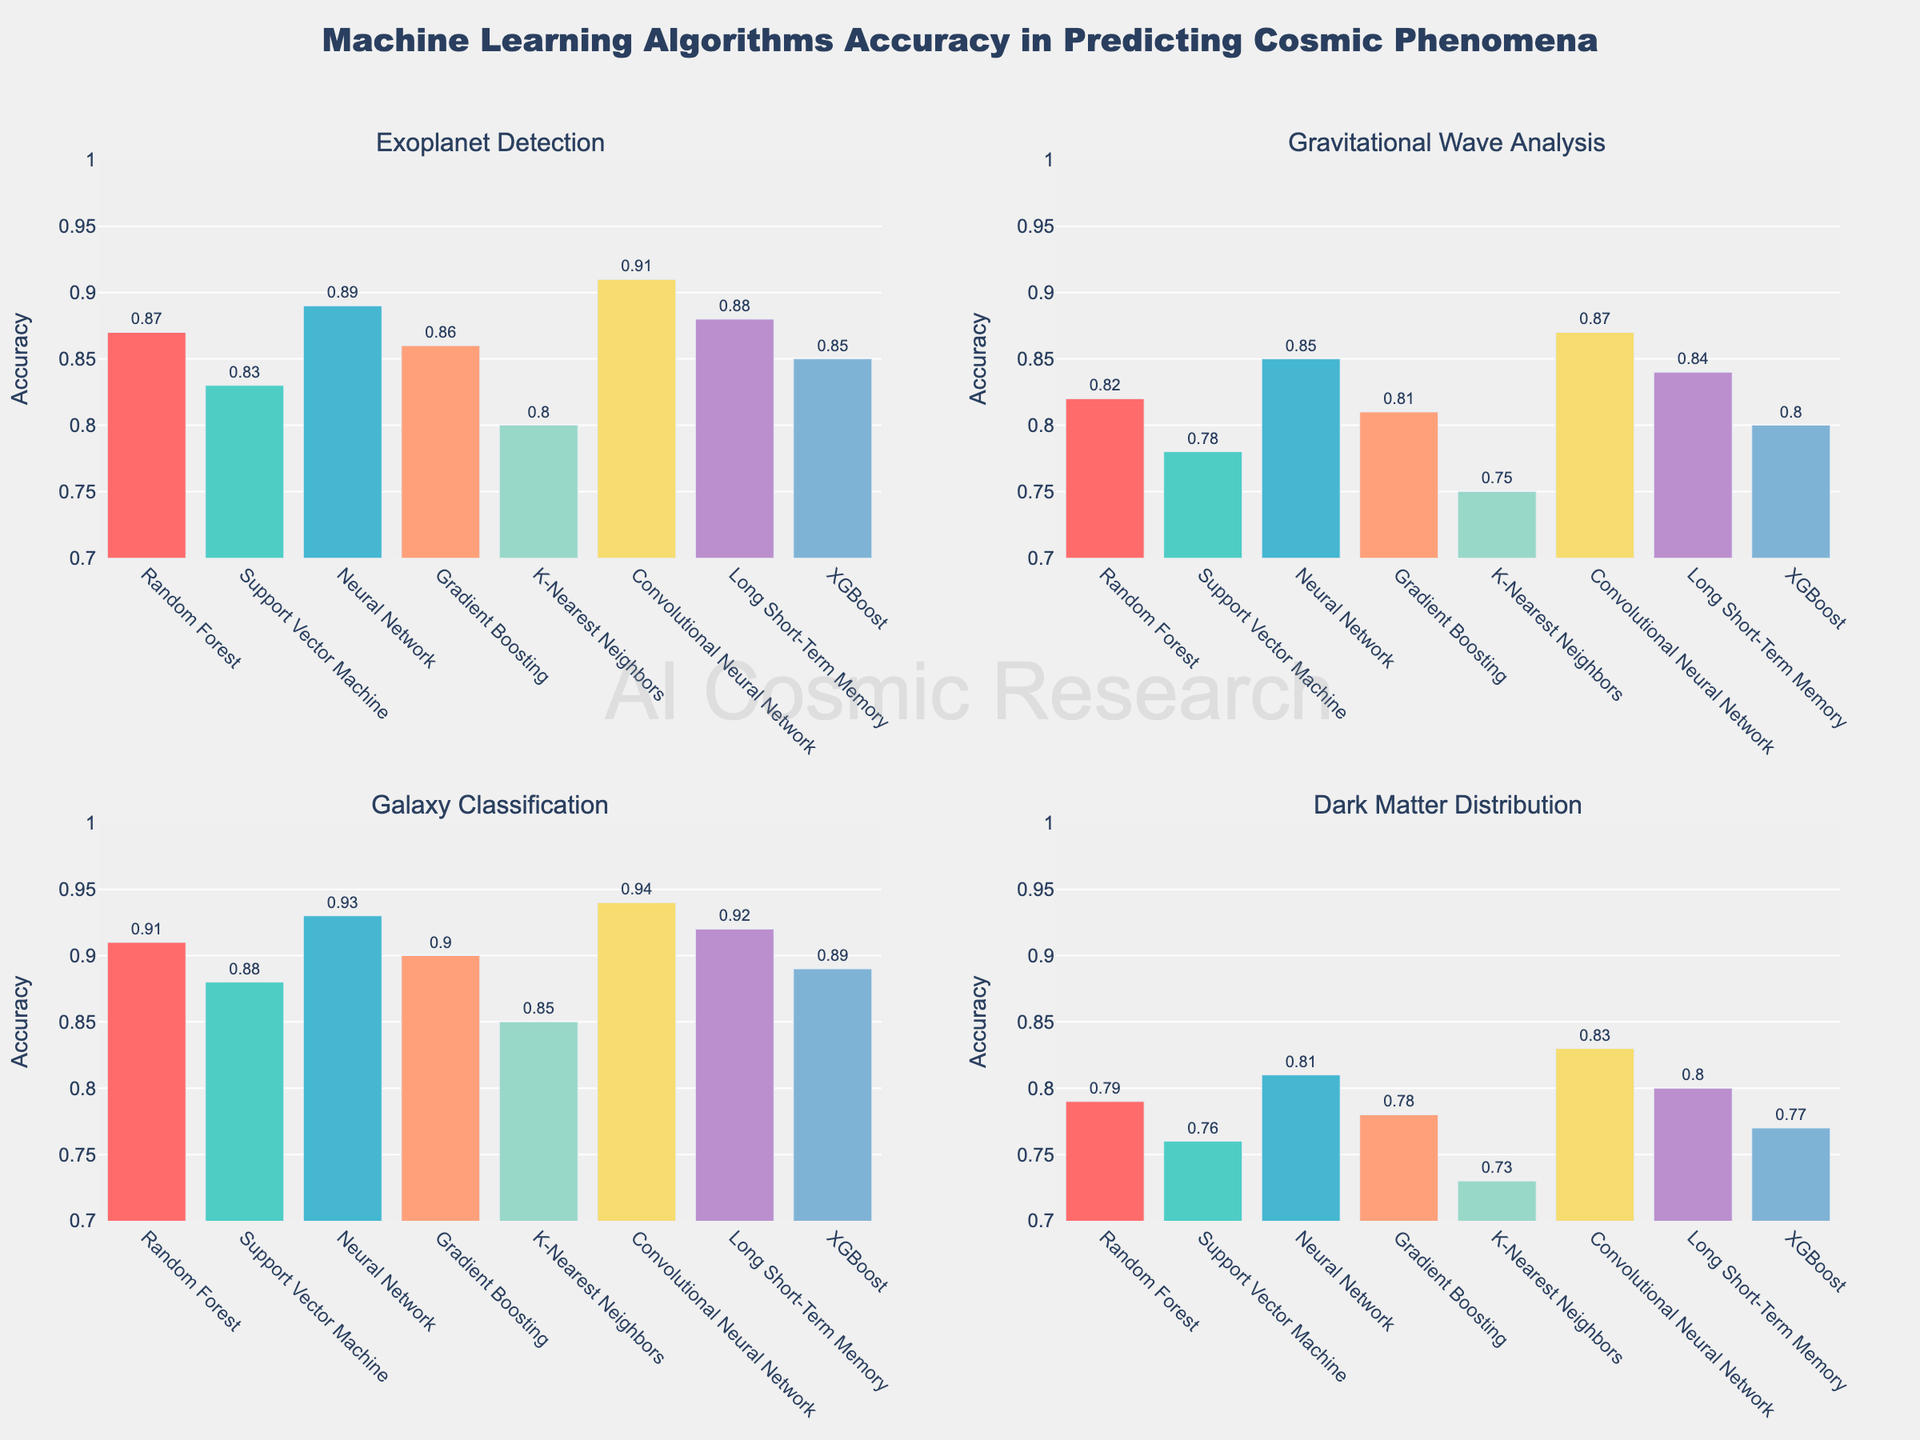What's the highest accuracy achieved by any algorithm in detecting Exoplanets? First, look at the 'Exoplanet Detection' subplot and identify the tallest bar. The tallest bar corresponds to the Convolutional Neural Network (CNN) algorithm with an accuracy of 0.91 (highlighted by its text label).
Answer: 0.91 Which phenomenon has the lowest overall accuracy across all algorithms? Evaluate all four subplots and note the lowest accuracies in each. Gravitational Wave Analysis and Dark Matter Distribution have noticeably lower maximum accuracies. Dark Matter Distribution has the lowest maximum accuracy, with 0.83 achieved by the CNN algorithm.
Answer: Dark Matter Distribution What is the difference in accuracy between the highest and lowest performing algorithms in Galaxy Classification? Identify the tallest and shortest bars in the Galaxy Classification subplot. Neural Network achieves the highest accuracy (0.94), while K-Nearest Neighbors achieves the lowest (0.85). Compute the difference: 0.94 - 0.85.
Answer: 0.09 On average, which algorithm performs the best across all phenomena? Calculate the average accuracy for each algorithm across the four phenomena. Neural Network shows consistently high accuracy: (0.89 + 0.85 + 0.93 + 0.81) / 4 = 0.87 on average. CNN 0.91, 0.87, 0.94, and 0.83 results in 0.88, thus making CNN the algorithm with the highest average accuracy.
Answer: Convolutional Neural Network Compare Random Forest and Support Vector Machine in terms of their accuracy in detecting Exoplanets. Which one is higher and by how much? Refer to the Exoplanet Detection subplot, Random Forest shows an accuracy of 0.87 and Support Vector Machine shows 0.83. The difference is calculated as: 0.87 - 0.83.
Answer: Random Forest by 0.04 Across all subplots, which algorithm appears most frequently as the second-highest in accuracy? In Exoplanet Detection, LSTM (0.88); in Gravitational Wave Analysis, LSTM (0.84); in Galaxy Classification, LSTM (0.92); in Dark Matter Distribution, LSTM (0.80). Thus, LSTM appears three times as the second-highest.
Answer: Long Short-Term Memory Is there any algorithm that performs worse than 0.75 on any phenomenon? Check each subplot for accuracies below 0.75. In Gravitational Wave Analysis, K-Nearest Neighbors performs at 0.75. Also in Dark Matter Distribution, it performs at 0.73. Thus, K-Nearest Neighbors performs worse than 0.75 in Dash Matter Distribution.
Answer: K-Nearest Neighbors Which phenomenon has the widest range of accuracy values among all algorithms? Calculate the range for each phenomenon: Exoplanet Detection (0.91 - 0.80 = 0.11), Gravitational Wave Analysis (0.87 - 0.75 = 0.12), Galaxy Classification (0.94 - 0.85 = 0.09), Dark Matter Distribution (0.83 - 0.73 = 0.10). Gravitational Wave Analysis has the widest range.
Answer: Gravitational Wave Analysis 